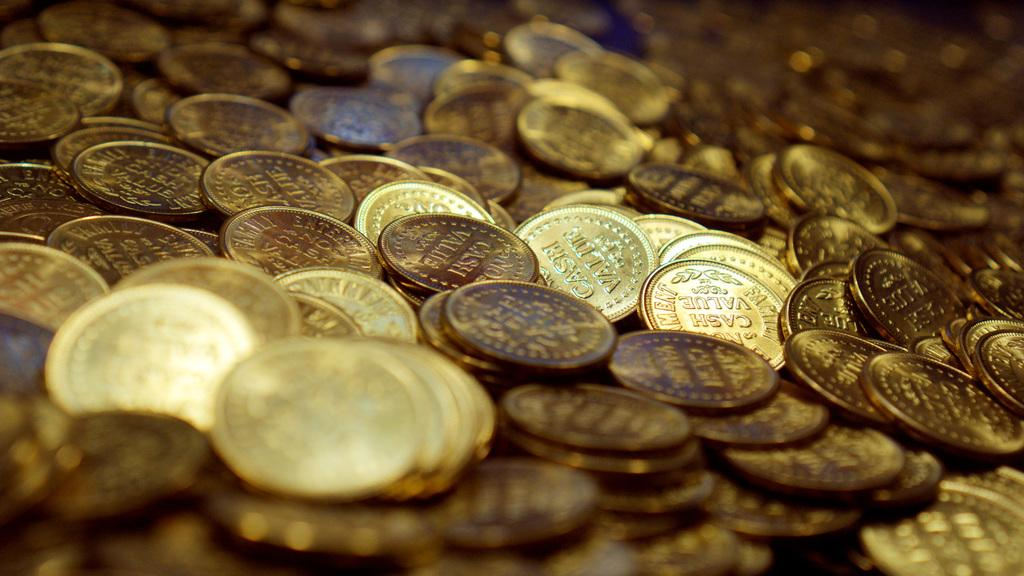<image>
Relay a brief, clear account of the picture shown. A pile of shiny tokens are each stamped with no cash value. 